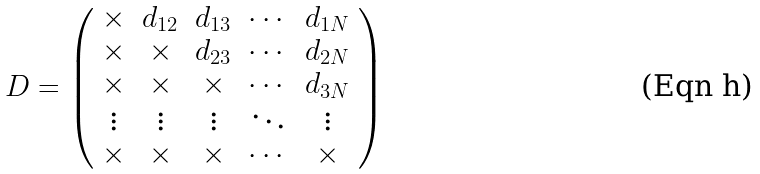<formula> <loc_0><loc_0><loc_500><loc_500>D = \left ( \begin{array} { c c c c c } \times & d _ { 1 2 } & d _ { 1 3 } & \cdots & d _ { 1 N } \\ \times & \times & d _ { 2 3 } & \cdots & d _ { 2 N } \\ \times & \times & \times & \cdots & d _ { 3 N } \\ \vdots & \vdots & \vdots & \ddots & \vdots \\ \times & \times & \times & \cdots & \times \\ \end{array} \right )</formula> 